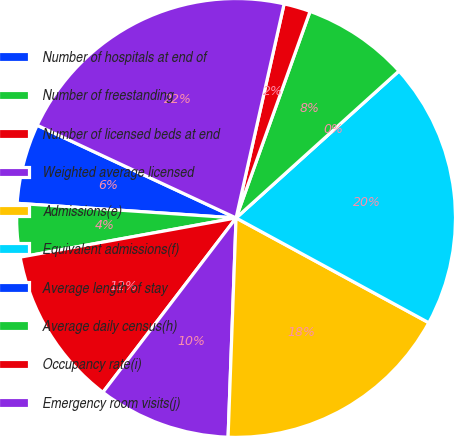Convert chart. <chart><loc_0><loc_0><loc_500><loc_500><pie_chart><fcel>Number of hospitals at end of<fcel>Number of freestanding<fcel>Number of licensed beds at end<fcel>Weighted average licensed<fcel>Admissions(e)<fcel>Equivalent admissions(f)<fcel>Average length of stay<fcel>Average daily census(h)<fcel>Occupancy rate(i)<fcel>Emergency room visits(j)<nl><fcel>5.88%<fcel>3.92%<fcel>11.76%<fcel>9.8%<fcel>17.65%<fcel>19.61%<fcel>0.0%<fcel>7.84%<fcel>1.96%<fcel>21.57%<nl></chart> 